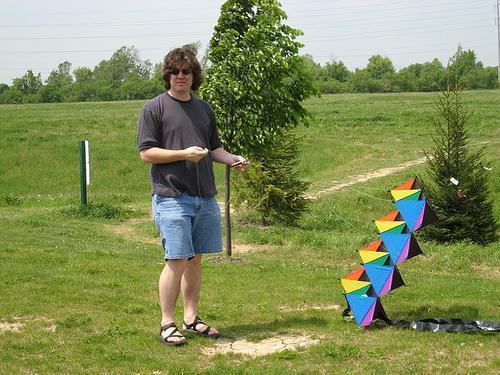How many people are shown?
Give a very brief answer. 1. 